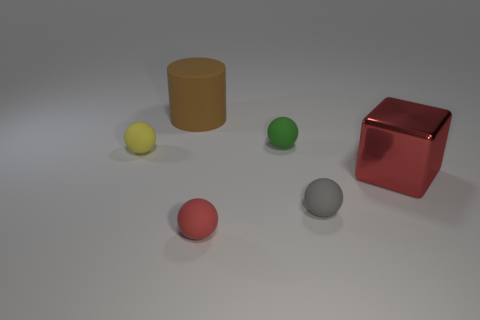Add 1 large blue rubber balls. How many objects exist? 7 Subtract all tiny red spheres. How many spheres are left? 3 Subtract all red spheres. How many spheres are left? 3 Subtract all cylinders. How many objects are left? 5 Add 2 big red objects. How many big red objects are left? 3 Add 6 big cyan metal objects. How many big cyan metal objects exist? 6 Subtract 0 yellow cubes. How many objects are left? 6 Subtract all gray balls. Subtract all gray blocks. How many balls are left? 3 Subtract all big brown things. Subtract all large red metal cubes. How many objects are left? 4 